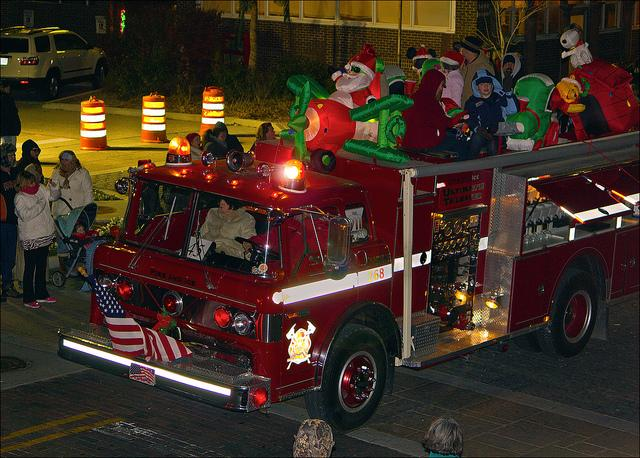What sort of Holiday parade is being feted here?

Choices:
A) christmas
B) st patricks
C) flag day
D) veterans day christmas 